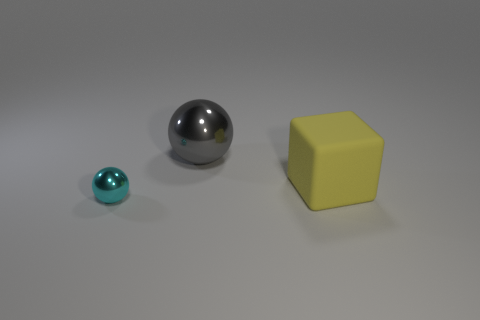What number of objects are right of the large gray metallic ball and to the left of the big gray sphere?
Give a very brief answer. 0. What number of other objects are the same shape as the tiny cyan thing?
Offer a terse response. 1. Is the number of large yellow matte blocks that are behind the yellow thing greater than the number of cyan metal objects?
Provide a short and direct response. No. What is the color of the thing on the left side of the big gray shiny object?
Your response must be concise. Cyan. What number of metal things are either cyan spheres or large objects?
Keep it short and to the point. 2. There is a metallic thing left of the sphere that is behind the cyan ball; is there a cyan shiny object in front of it?
Give a very brief answer. No. There is a large gray metal sphere; how many big balls are on the right side of it?
Give a very brief answer. 0. What number of large things are gray things or yellow matte blocks?
Make the answer very short. 2. The metal object to the right of the cyan shiny sphere has what shape?
Your answer should be very brief. Sphere. Are there any spheres that have the same color as the matte block?
Give a very brief answer. No. 